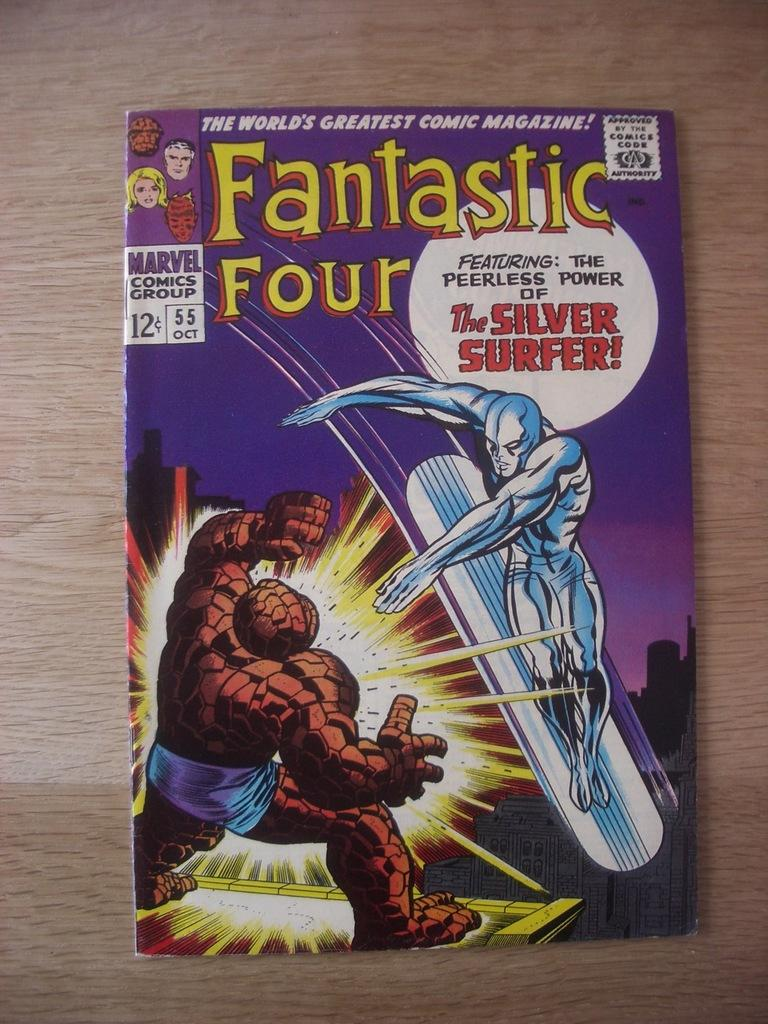<image>
Render a clear and concise summary of the photo. A copy of the Fantastic Four magazine featuring the Silver Surfer. 